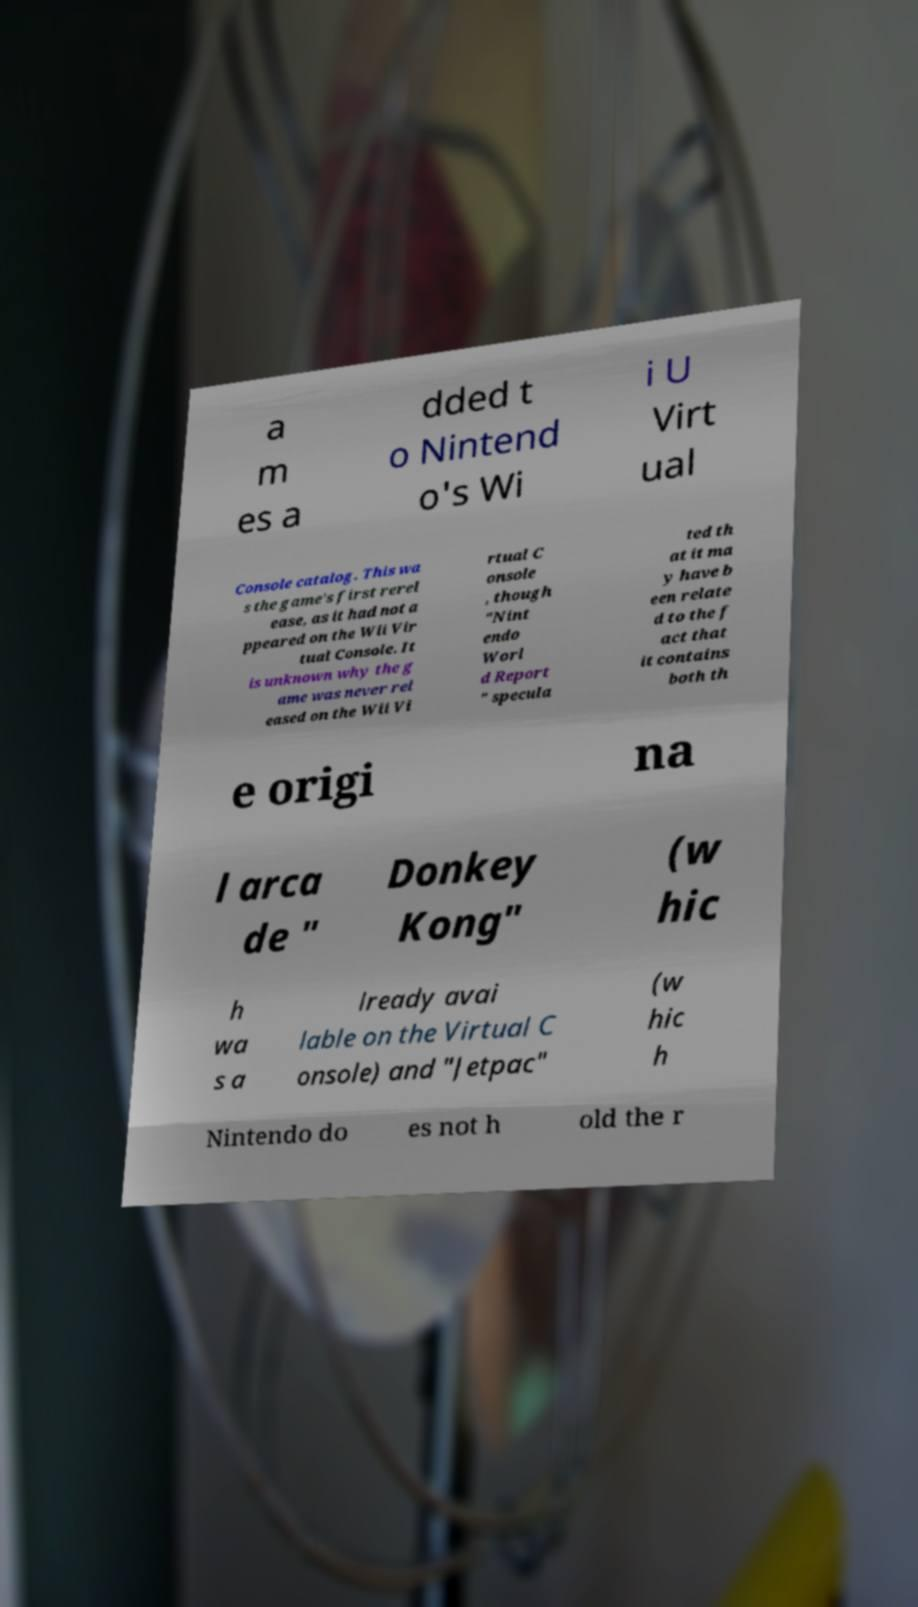I need the written content from this picture converted into text. Can you do that? a m es a dded t o Nintend o's Wi i U Virt ual Console catalog. This wa s the game's first rerel ease, as it had not a ppeared on the Wii Vir tual Console. It is unknown why the g ame was never rel eased on the Wii Vi rtual C onsole , though "Nint endo Worl d Report " specula ted th at it ma y have b een relate d to the f act that it contains both th e origi na l arca de " Donkey Kong" (w hic h wa s a lready avai lable on the Virtual C onsole) and "Jetpac" (w hic h Nintendo do es not h old the r 